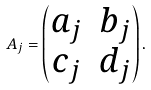Convert formula to latex. <formula><loc_0><loc_0><loc_500><loc_500>A _ { j } = \begin{pmatrix} a _ { j } & b _ { j } \\ c _ { j } & d _ { j } \end{pmatrix} .</formula> 